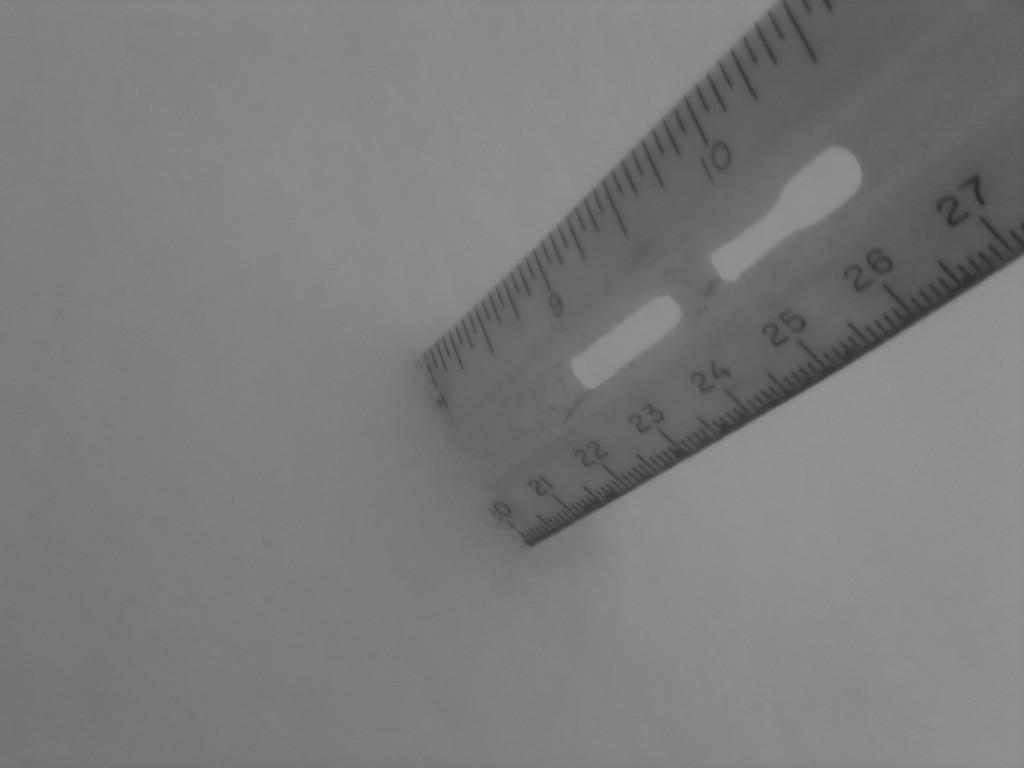<image>
Offer a succinct explanation of the picture presented. A ruler showing the depth of the liquid is 20 centimeters 